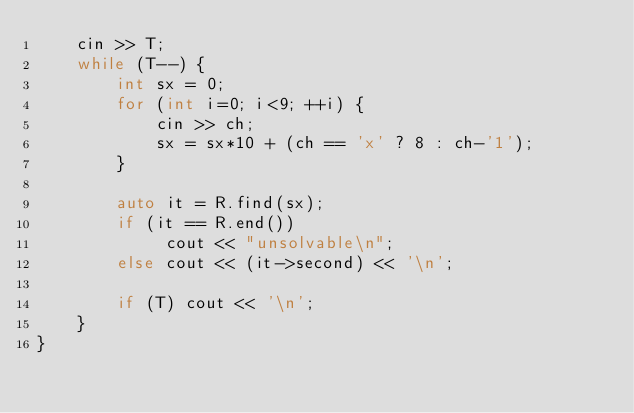Convert code to text. <code><loc_0><loc_0><loc_500><loc_500><_C++_>    cin >> T;
    while (T--) {
        int sx = 0;
        for (int i=0; i<9; ++i) {
            cin >> ch;
            sx = sx*10 + (ch == 'x' ? 8 : ch-'1');
        }

        auto it = R.find(sx);
        if (it == R.end())
             cout << "unsolvable\n";
        else cout << (it->second) << '\n';

        if (T) cout << '\n';
    }
}
</code> 